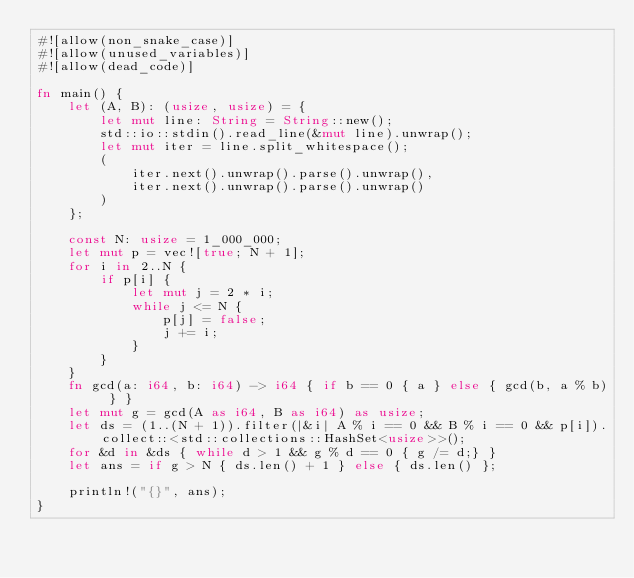Convert code to text. <code><loc_0><loc_0><loc_500><loc_500><_Rust_>#![allow(non_snake_case)]
#![allow(unused_variables)]
#![allow(dead_code)]

fn main() {
    let (A, B): (usize, usize) = {
        let mut line: String = String::new();
        std::io::stdin().read_line(&mut line).unwrap();
        let mut iter = line.split_whitespace();
        (
            iter.next().unwrap().parse().unwrap(),
            iter.next().unwrap().parse().unwrap()
        )
    };

    const N: usize = 1_000_000;
    let mut p = vec![true; N + 1];
    for i in 2..N {
        if p[i] {
            let mut j = 2 * i;
            while j <= N {
                p[j] = false;
                j += i;
            }
        }
    }
    fn gcd(a: i64, b: i64) -> i64 { if b == 0 { a } else { gcd(b, a % b) } }
    let mut g = gcd(A as i64, B as i64) as usize;
    let ds = (1..(N + 1)).filter(|&i| A % i == 0 && B % i == 0 && p[i]).collect::<std::collections::HashSet<usize>>();
    for &d in &ds { while d > 1 && g % d == 0 { g /= d;} }
    let ans = if g > N { ds.len() + 1 } else { ds.len() };

    println!("{}", ans);
}
</code> 